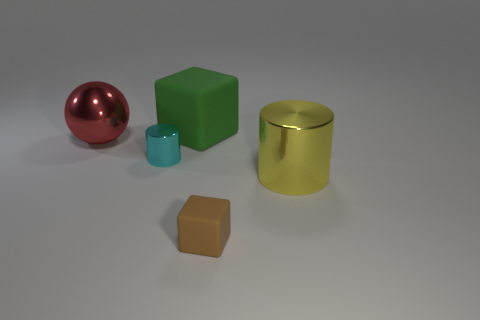Add 5 small objects. How many objects exist? 10 Subtract all blocks. How many objects are left? 3 Add 2 cyan shiny cylinders. How many cyan shiny cylinders exist? 3 Subtract 0 brown balls. How many objects are left? 5 Subtract all green cubes. Subtract all tiny matte things. How many objects are left? 3 Add 1 green matte objects. How many green matte objects are left? 2 